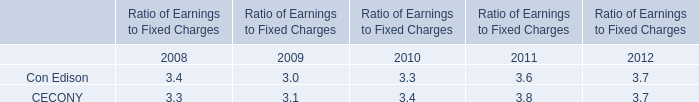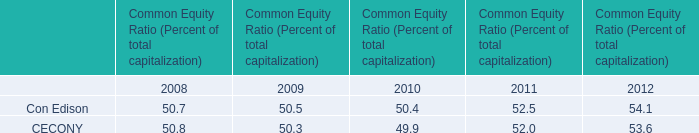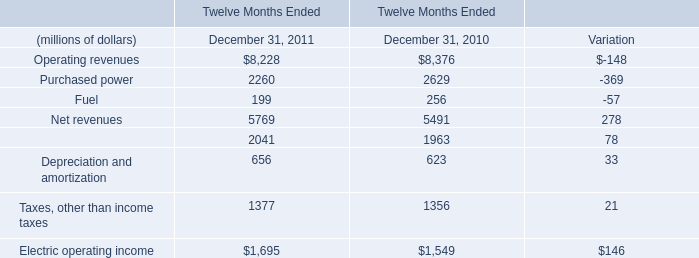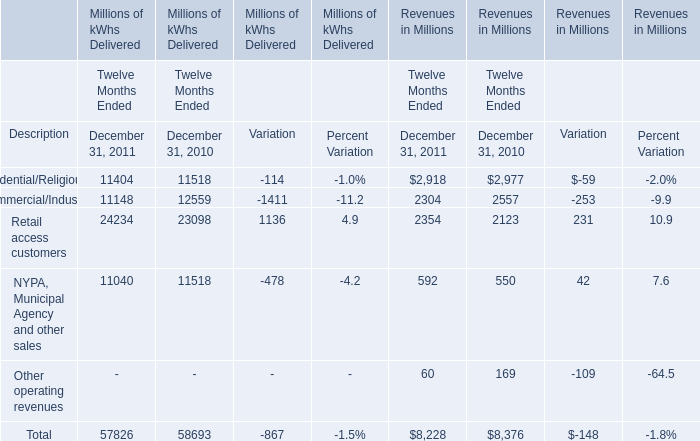How many kinds of revenue in millions in 2011 are greater than those in the previous year? 
Answer: NYPA, Municipal Agency and other sales and Retail access customers. 